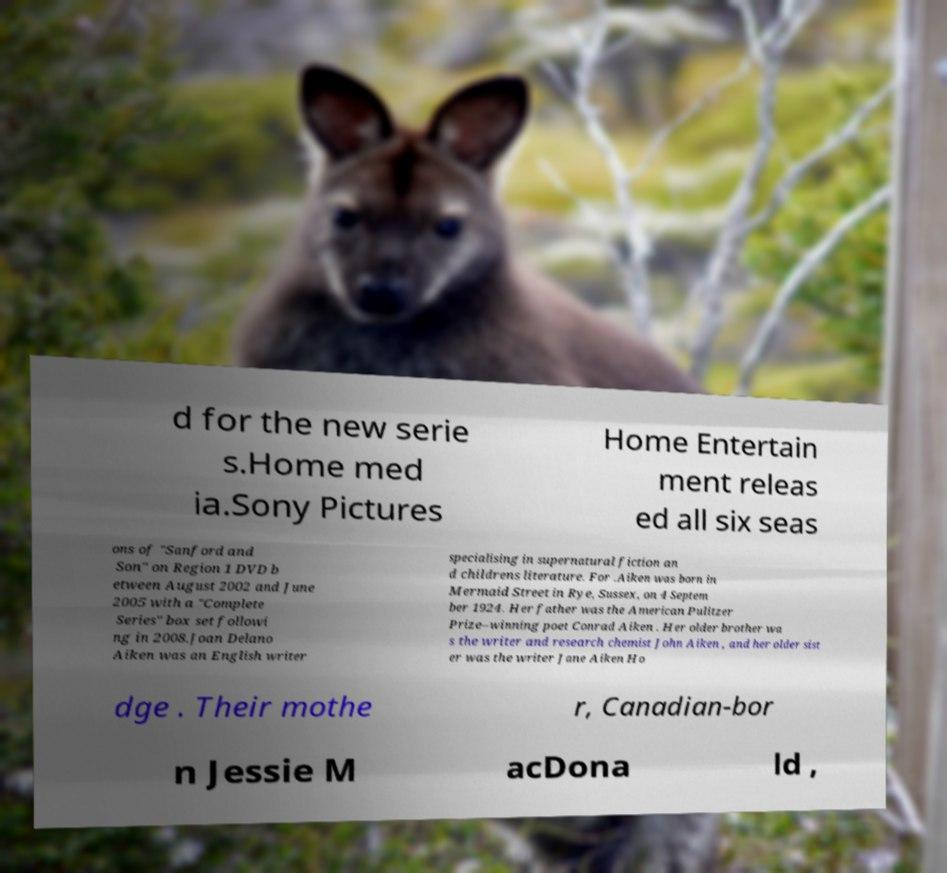Please identify and transcribe the text found in this image. d for the new serie s.Home med ia.Sony Pictures Home Entertain ment releas ed all six seas ons of "Sanford and Son" on Region 1 DVD b etween August 2002 and June 2005 with a "Complete Series" box set followi ng in 2008.Joan Delano Aiken was an English writer specialising in supernatural fiction an d childrens literature. For .Aiken was born in Mermaid Street in Rye, Sussex, on 4 Septem ber 1924. Her father was the American Pulitzer Prize–winning poet Conrad Aiken . Her older brother wa s the writer and research chemist John Aiken , and her older sist er was the writer Jane Aiken Ho dge . Their mothe r, Canadian-bor n Jessie M acDona ld , 